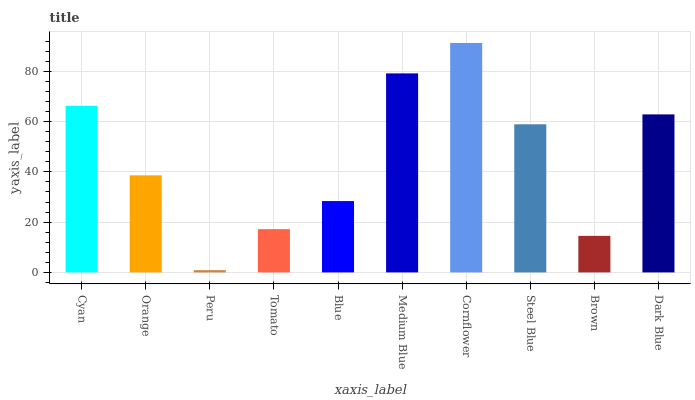Is Peru the minimum?
Answer yes or no. Yes. Is Cornflower the maximum?
Answer yes or no. Yes. Is Orange the minimum?
Answer yes or no. No. Is Orange the maximum?
Answer yes or no. No. Is Cyan greater than Orange?
Answer yes or no. Yes. Is Orange less than Cyan?
Answer yes or no. Yes. Is Orange greater than Cyan?
Answer yes or no. No. Is Cyan less than Orange?
Answer yes or no. No. Is Steel Blue the high median?
Answer yes or no. Yes. Is Orange the low median?
Answer yes or no. Yes. Is Blue the high median?
Answer yes or no. No. Is Brown the low median?
Answer yes or no. No. 